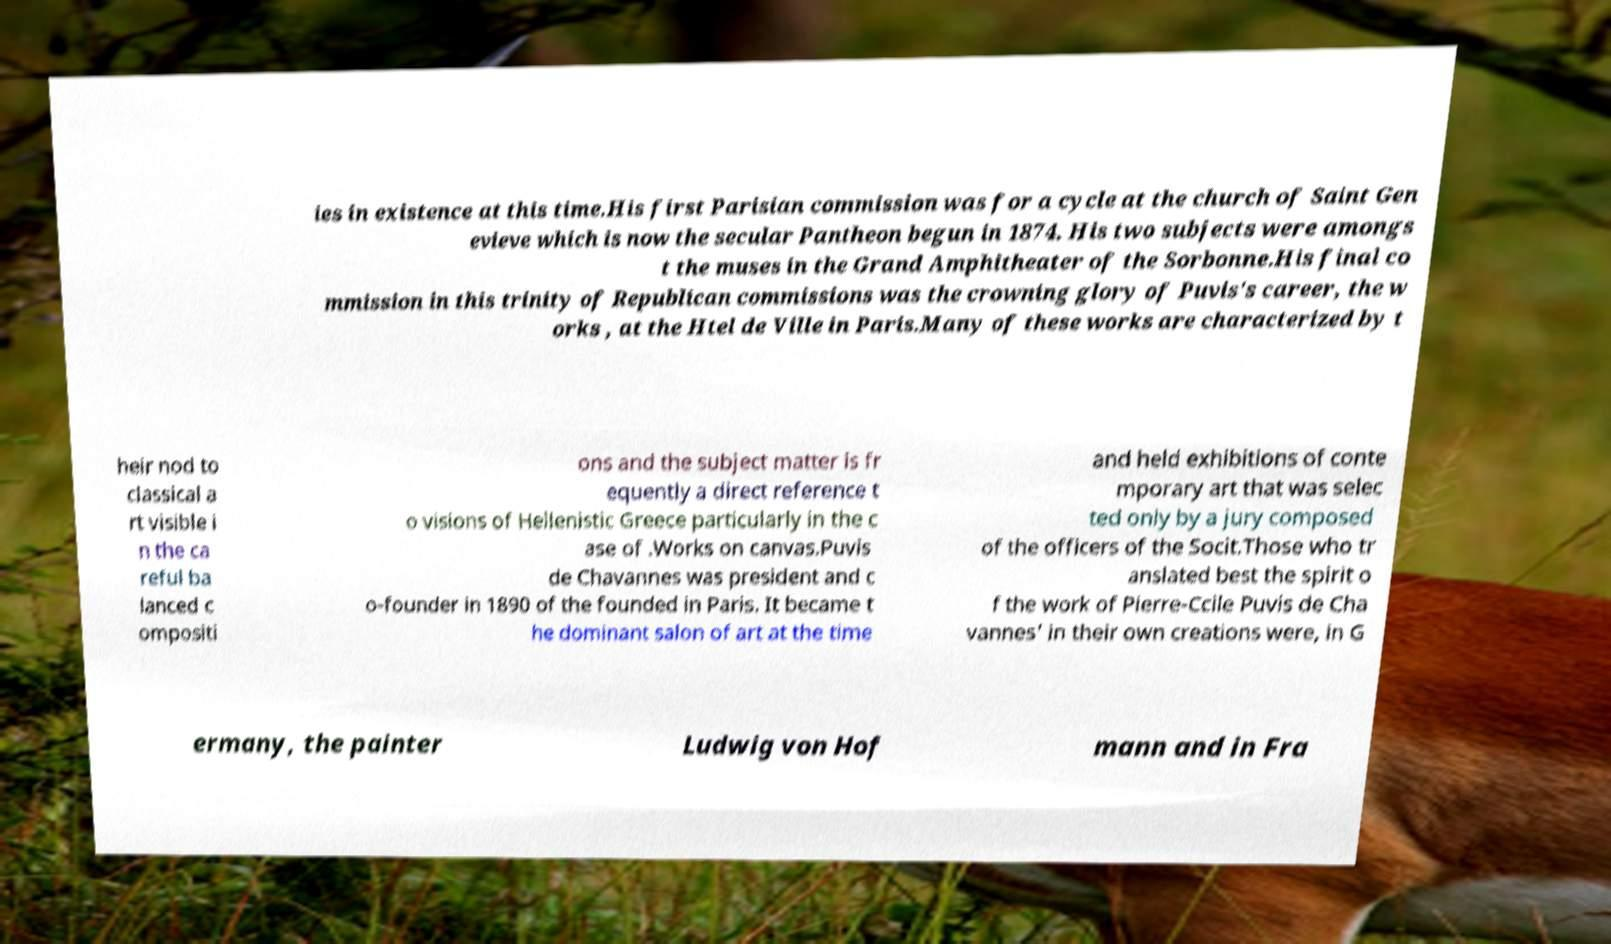Please read and relay the text visible in this image. What does it say? ies in existence at this time.His first Parisian commission was for a cycle at the church of Saint Gen evieve which is now the secular Pantheon begun in 1874. His two subjects were amongs t the muses in the Grand Amphitheater of the Sorbonne.His final co mmission in this trinity of Republican commissions was the crowning glory of Puvis's career, the w orks , at the Htel de Ville in Paris.Many of these works are characterized by t heir nod to classical a rt visible i n the ca reful ba lanced c ompositi ons and the subject matter is fr equently a direct reference t o visions of Hellenistic Greece particularly in the c ase of .Works on canvas.Puvis de Chavannes was president and c o-founder in 1890 of the founded in Paris. It became t he dominant salon of art at the time and held exhibitions of conte mporary art that was selec ted only by a jury composed of the officers of the Socit.Those who tr anslated best the spirit o f the work of Pierre-Ccile Puvis de Cha vannes' in their own creations were, in G ermany, the painter Ludwig von Hof mann and in Fra 